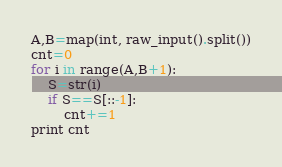Convert code to text. <code><loc_0><loc_0><loc_500><loc_500><_Python_>A,B=map(int, raw_input().split())
cnt=0
for i in range(A,B+1):
	S=str(i)
	if S==S[::-1]:
		cnt+=1
print cnt
</code> 